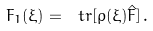Convert formula to latex. <formula><loc_0><loc_0><loc_500><loc_500>F _ { 1 } ( \xi ) = \ t r [ \rho ( \xi ) \hat { F } ] \, .</formula> 